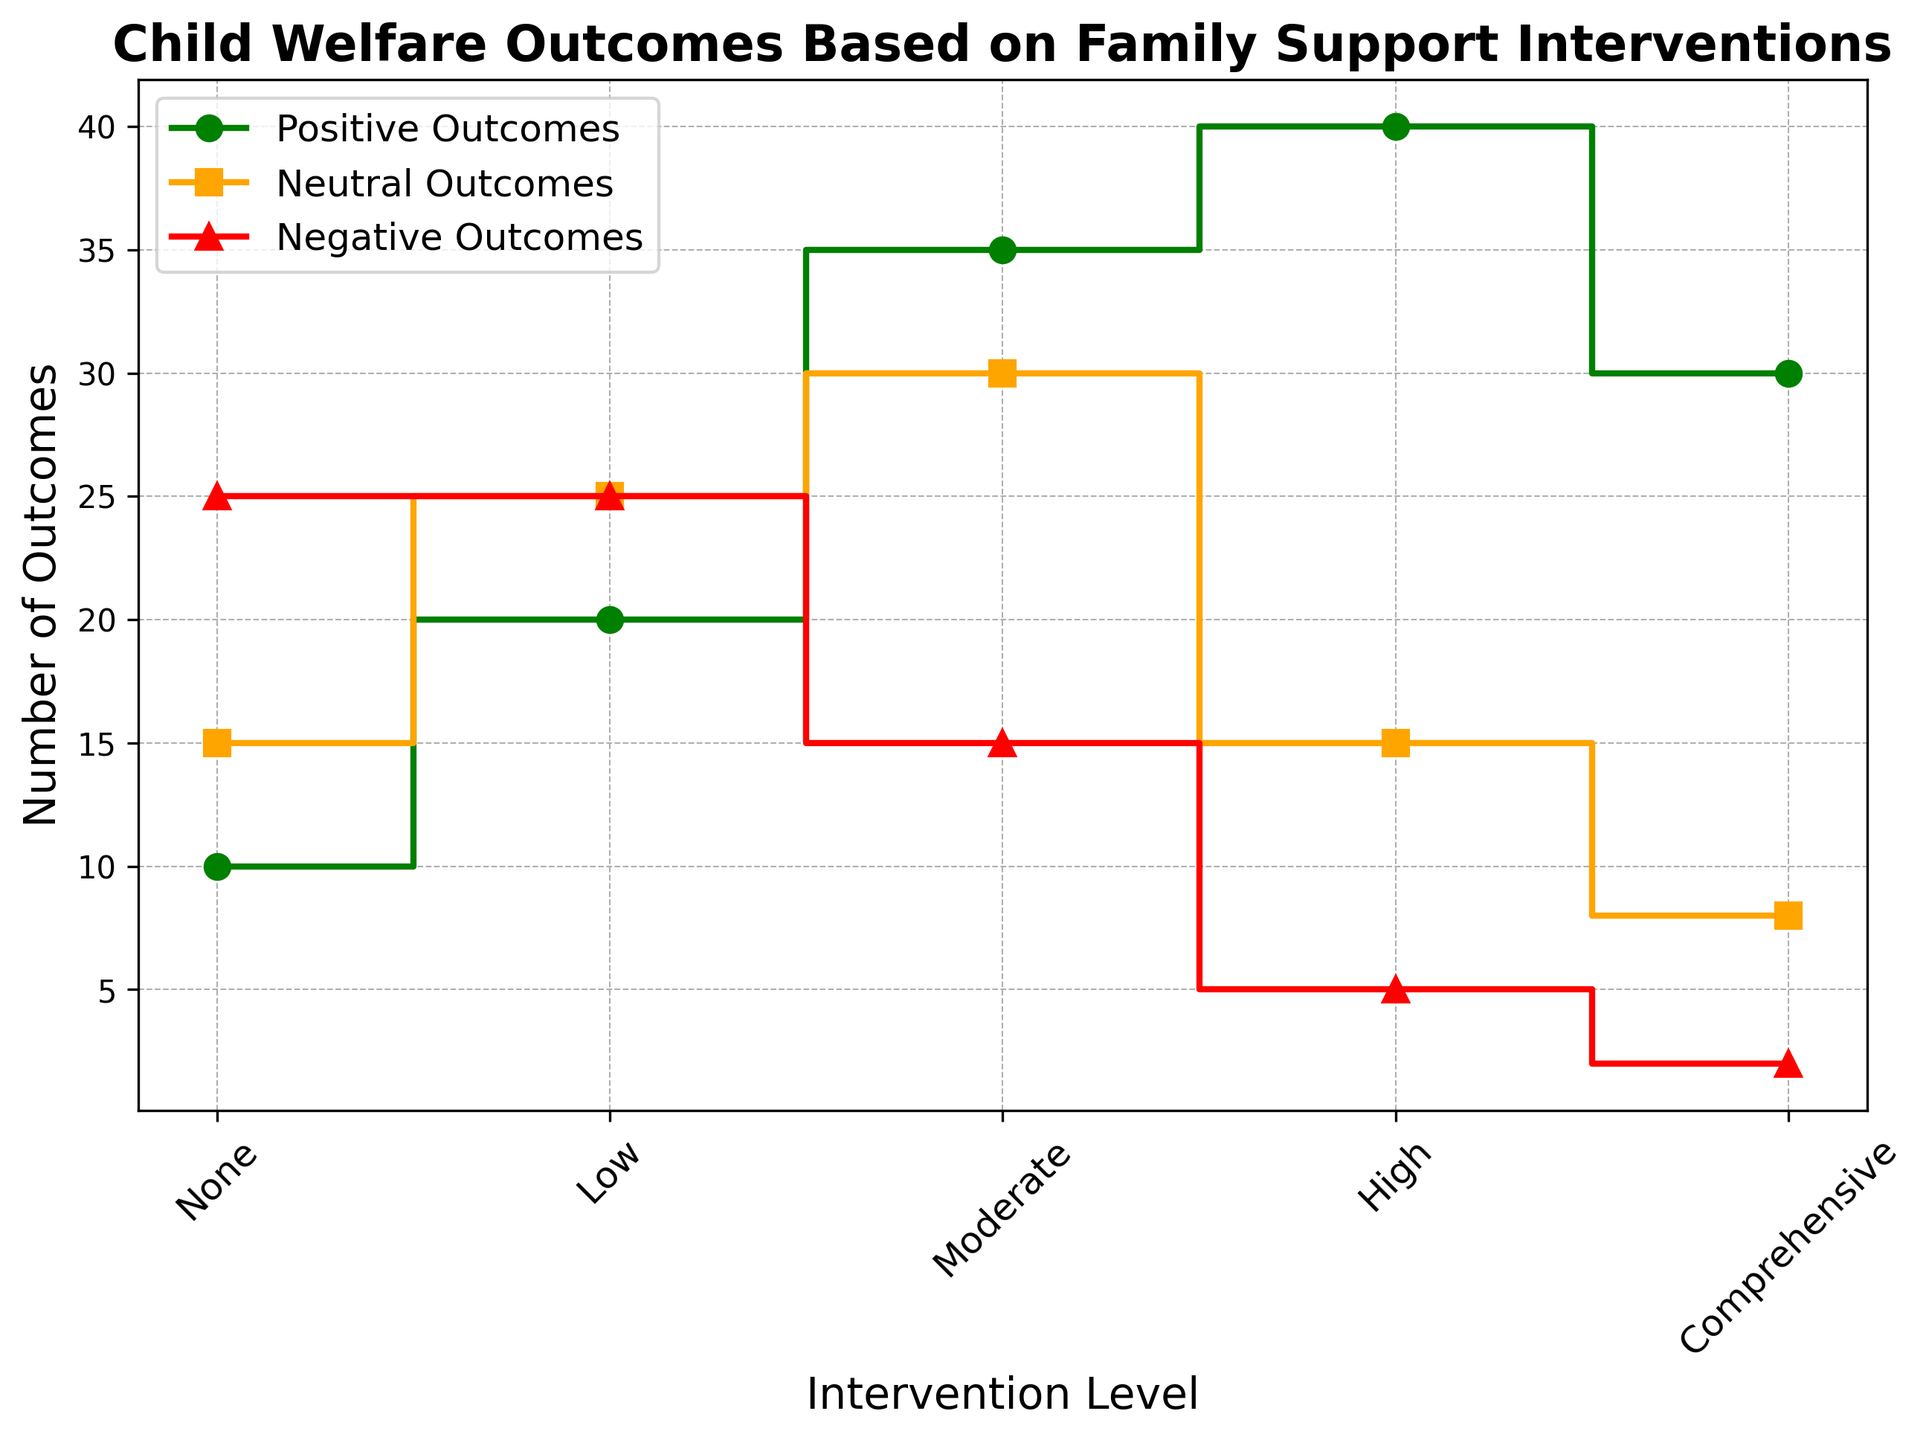What's the largest number of positive outcomes and at which intervention level does it occur? By looking at the green lines for positive outcomes, the highest value is 40, which occurs at the 'High' intervention level.
Answer: 40, High Which intervention level has the smallest number of negative outcomes? The red lines represent negative outcomes. The smallest value is 2, which occurs at the 'Comprehensive' level.
Answer: Comprehensive How many total outcomes (positive, neutral, negative) are there at the 'Moderate' intervention level? At 'Moderate' level: Positive = 35, Neutral = 30, Negative = 15. Total = 35 + 30 + 15 = 80.
Answer: 80 Compare the number of neutral outcomes at 'Low' and 'High' intervention levels. Which has more? The orange lines indicate neutral outcomes. 'Low' has 25 neutral outcomes while 'High' has 15. Therefore, 'Low' has more neutral outcomes.
Answer: Low What is the difference between the number of children served at 'None' and 'Comprehensive' intervention levels? 'None' has 50 children served, and 'Comprehensive' has 40. The difference is 50 - 40 = 10.
Answer: 10 Which intervention level has the highest number of positive outcomes, and how many children were served at this level? The highest number of positive outcomes is 40 at the 'High' intervention level, which served 60 children.
Answer: High, 60 What is the total number of positive outcomes across all intervention levels? Sum of positive outcomes: 10 (None) + 20 (Low) + 35 (Moderate) + 40 (High) + 30 (Comprehensive) = 135.
Answer: 135 Comparing 'High' and 'Moderate' intervention levels, which has fewer negative outcomes and by how much? 'High' has 5 negative outcomes, and 'Moderate' has 15. Difference = 15 - 5 = 10.
Answer: High, 10 What is the average number of positive outcomes for 'None,' 'Low,' and 'Moderate' intervention levels? Positive outcomes: None = 10, Low = 20, Moderate = 35. Average = (10 + 20 + 35) / 3 = 65 / 3 ≈ 21.67.
Answer: 21.67 Which intervention level has the most balanced distribution of outcomes (positive, neutral, negative)? 'Moderate' seems most balanced with Positive = 35, Neutral = 30, and Negative = 15. The values are relatively close compared to other levels.
Answer: Moderate 